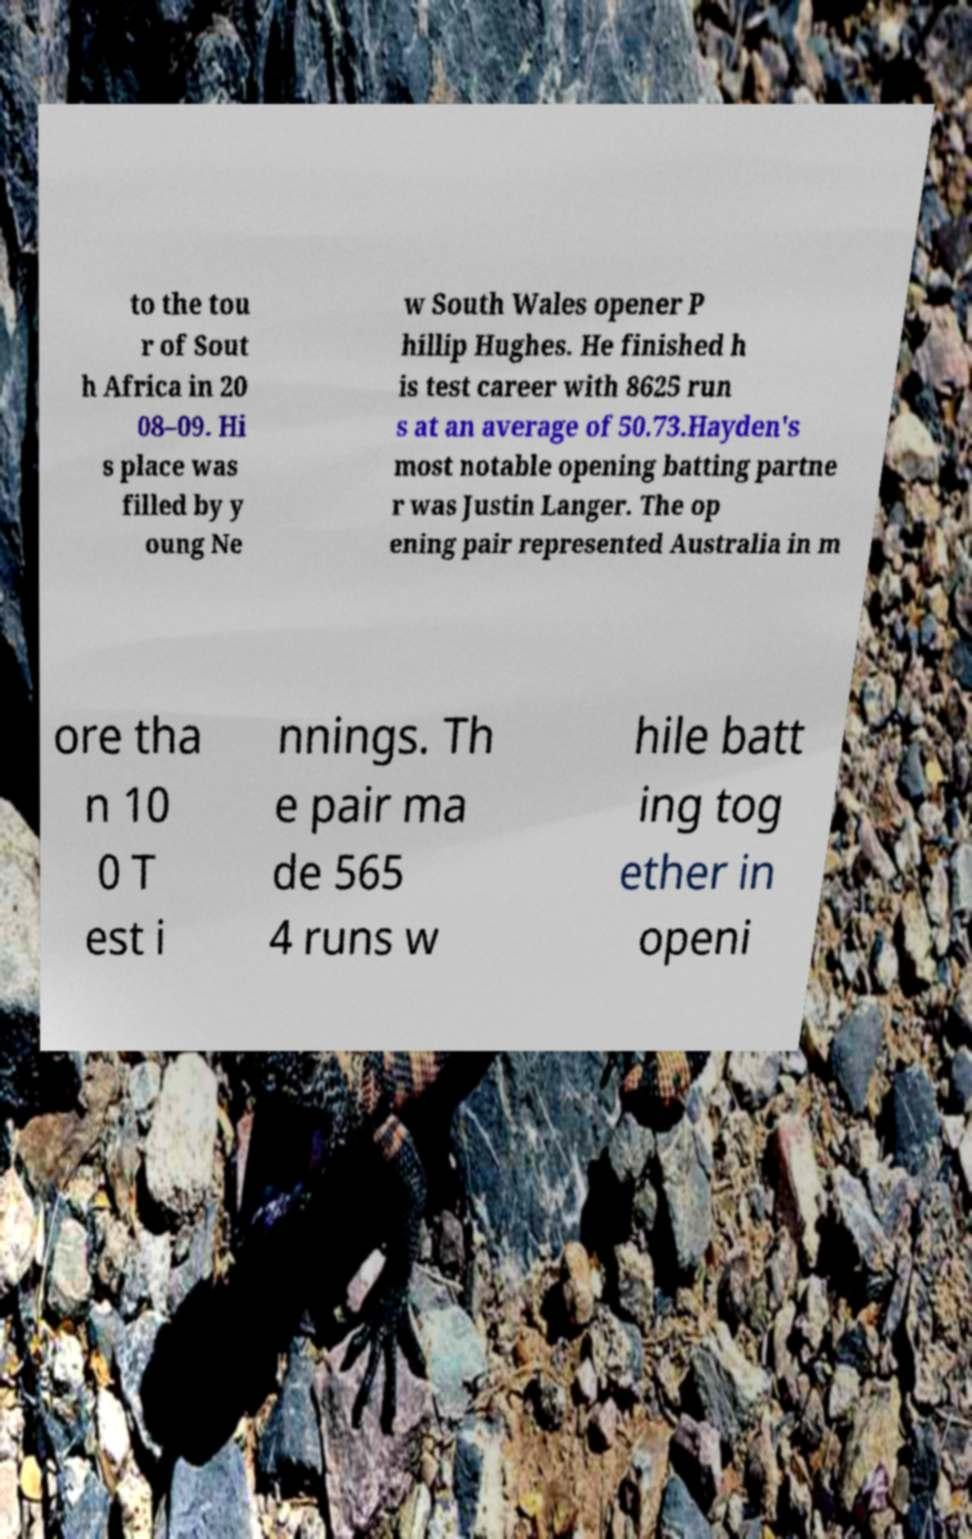What messages or text are displayed in this image? I need them in a readable, typed format. to the tou r of Sout h Africa in 20 08–09. Hi s place was filled by y oung Ne w South Wales opener P hillip Hughes. He finished h is test career with 8625 run s at an average of 50.73.Hayden's most notable opening batting partne r was Justin Langer. The op ening pair represented Australia in m ore tha n 10 0 T est i nnings. Th e pair ma de 565 4 runs w hile batt ing tog ether in openi 